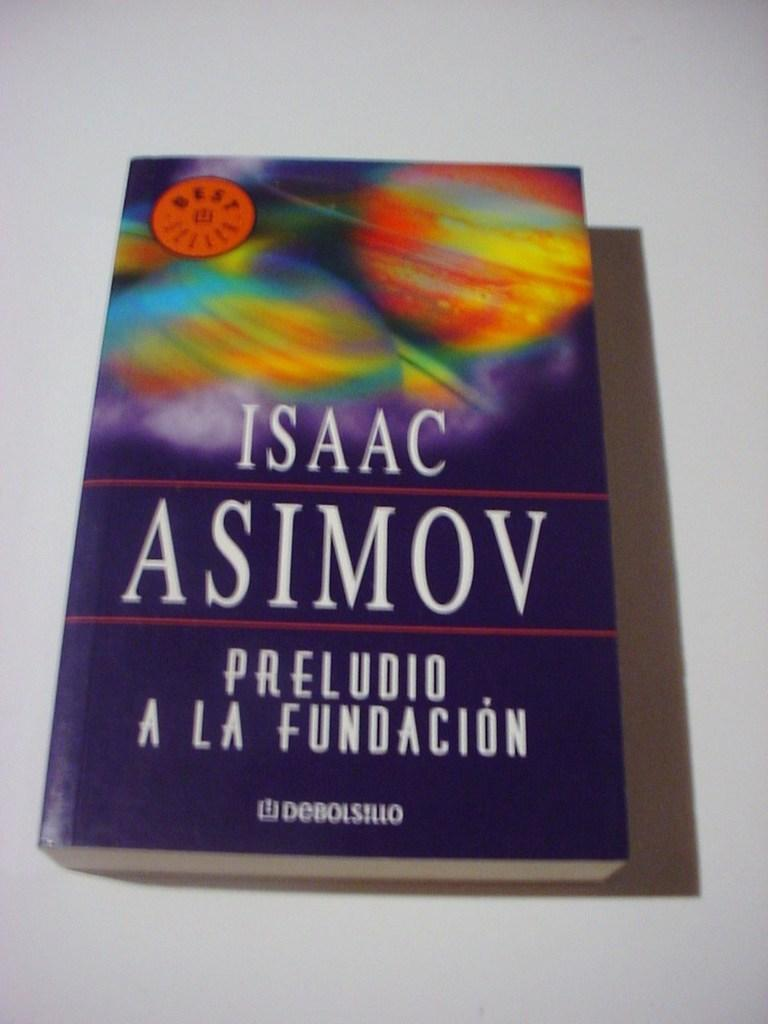Provide a one-sentence caption for the provided image. Isaac Asimov's book has a purple cover and spanish writing. 